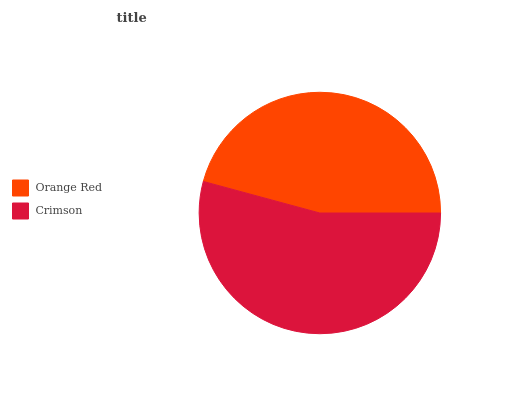Is Orange Red the minimum?
Answer yes or no. Yes. Is Crimson the maximum?
Answer yes or no. Yes. Is Crimson the minimum?
Answer yes or no. No. Is Crimson greater than Orange Red?
Answer yes or no. Yes. Is Orange Red less than Crimson?
Answer yes or no. Yes. Is Orange Red greater than Crimson?
Answer yes or no. No. Is Crimson less than Orange Red?
Answer yes or no. No. Is Crimson the high median?
Answer yes or no. Yes. Is Orange Red the low median?
Answer yes or no. Yes. Is Orange Red the high median?
Answer yes or no. No. Is Crimson the low median?
Answer yes or no. No. 